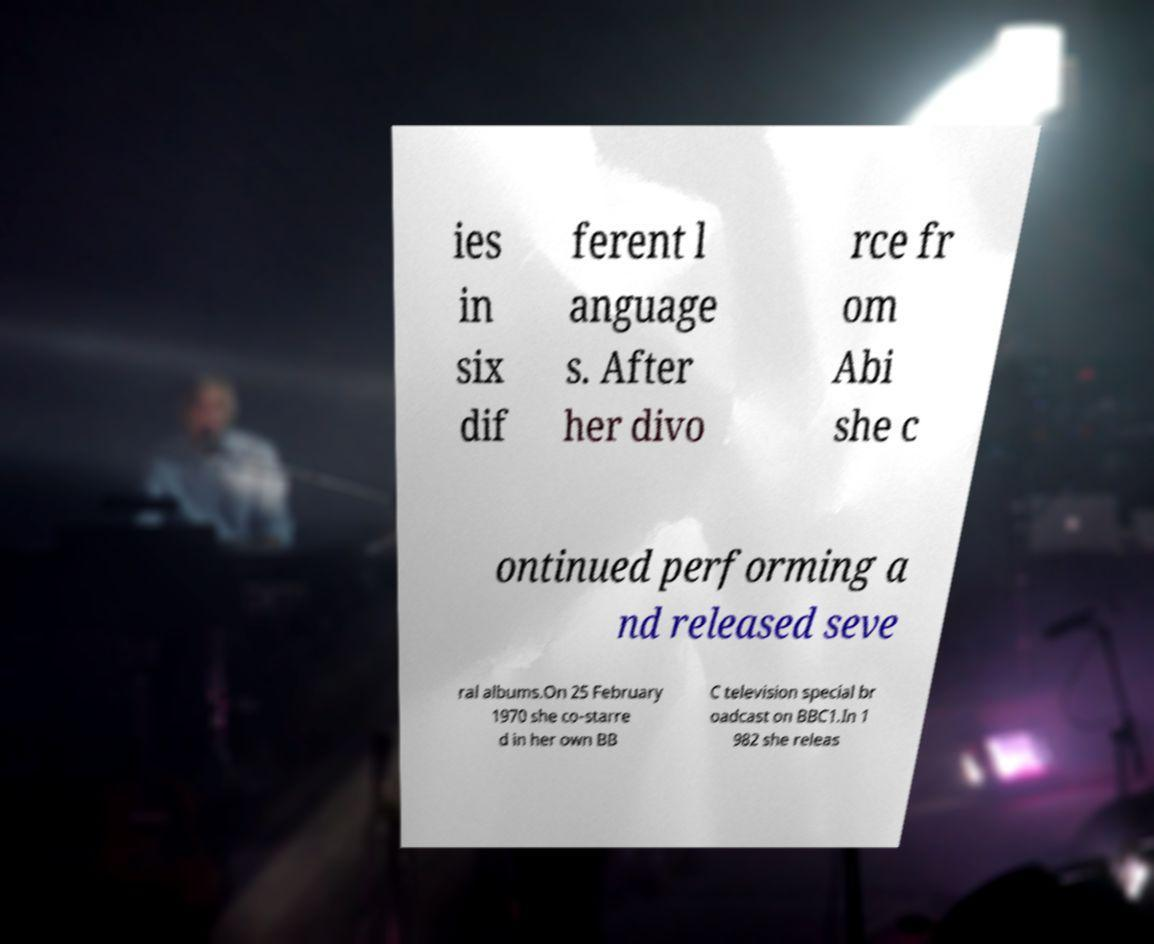Please read and relay the text visible in this image. What does it say? ies in six dif ferent l anguage s. After her divo rce fr om Abi she c ontinued performing a nd released seve ral albums.On 25 February 1970 she co-starre d in her own BB C television special br oadcast on BBC1.In 1 982 she releas 